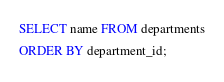Convert code to text. <code><loc_0><loc_0><loc_500><loc_500><_SQL_>SELECT name FROM departments
ORDER BY department_id;</code> 